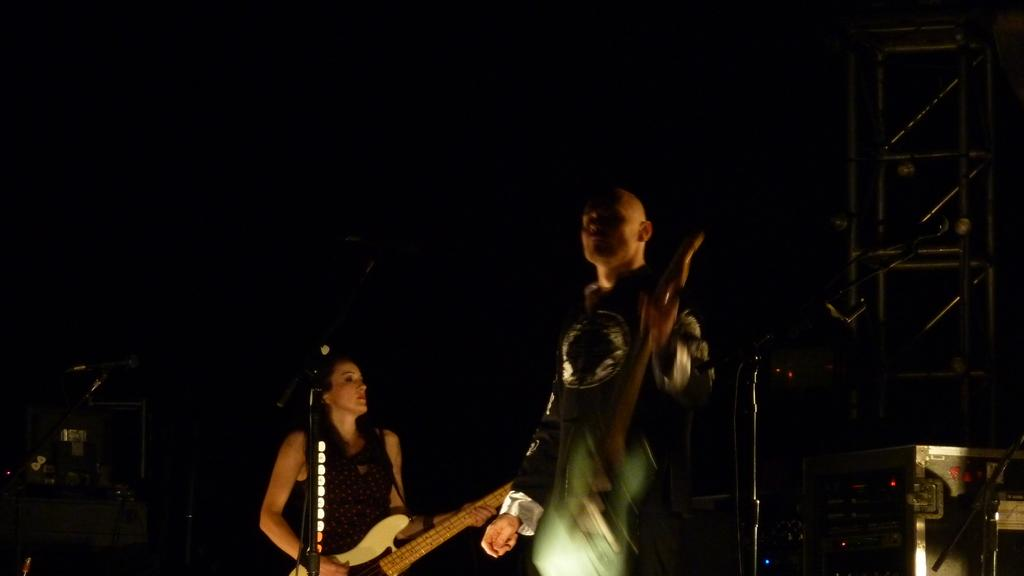What is the person on the right side of the image holding? The person on the right is holding a guitar. What is the woman on the left side of the image doing? The woman on the left is playing a guitar. How many people are present in the image? There are two people in the image, one on the right and one on the left. What type of surprise is the person on the right about to reveal in the image? There is no indication of a surprise in the image; the person on the right is simply holding a guitar. What type of laborer is the woman on the left in the image? The woman on the left is not depicted as a laborer in the image; she is playing a guitar. 